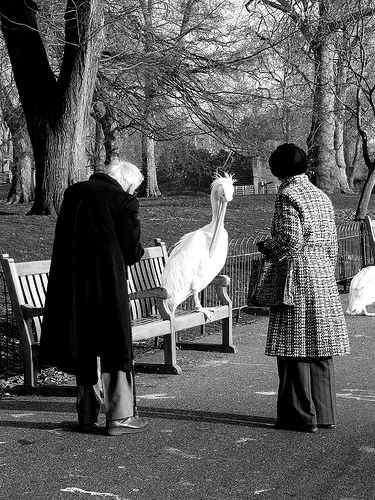Please provide a short description for this region: [0.64, 0.0, 0.87, 0.39]. Part of a tall tree, showcasing its textured bark and branches. 